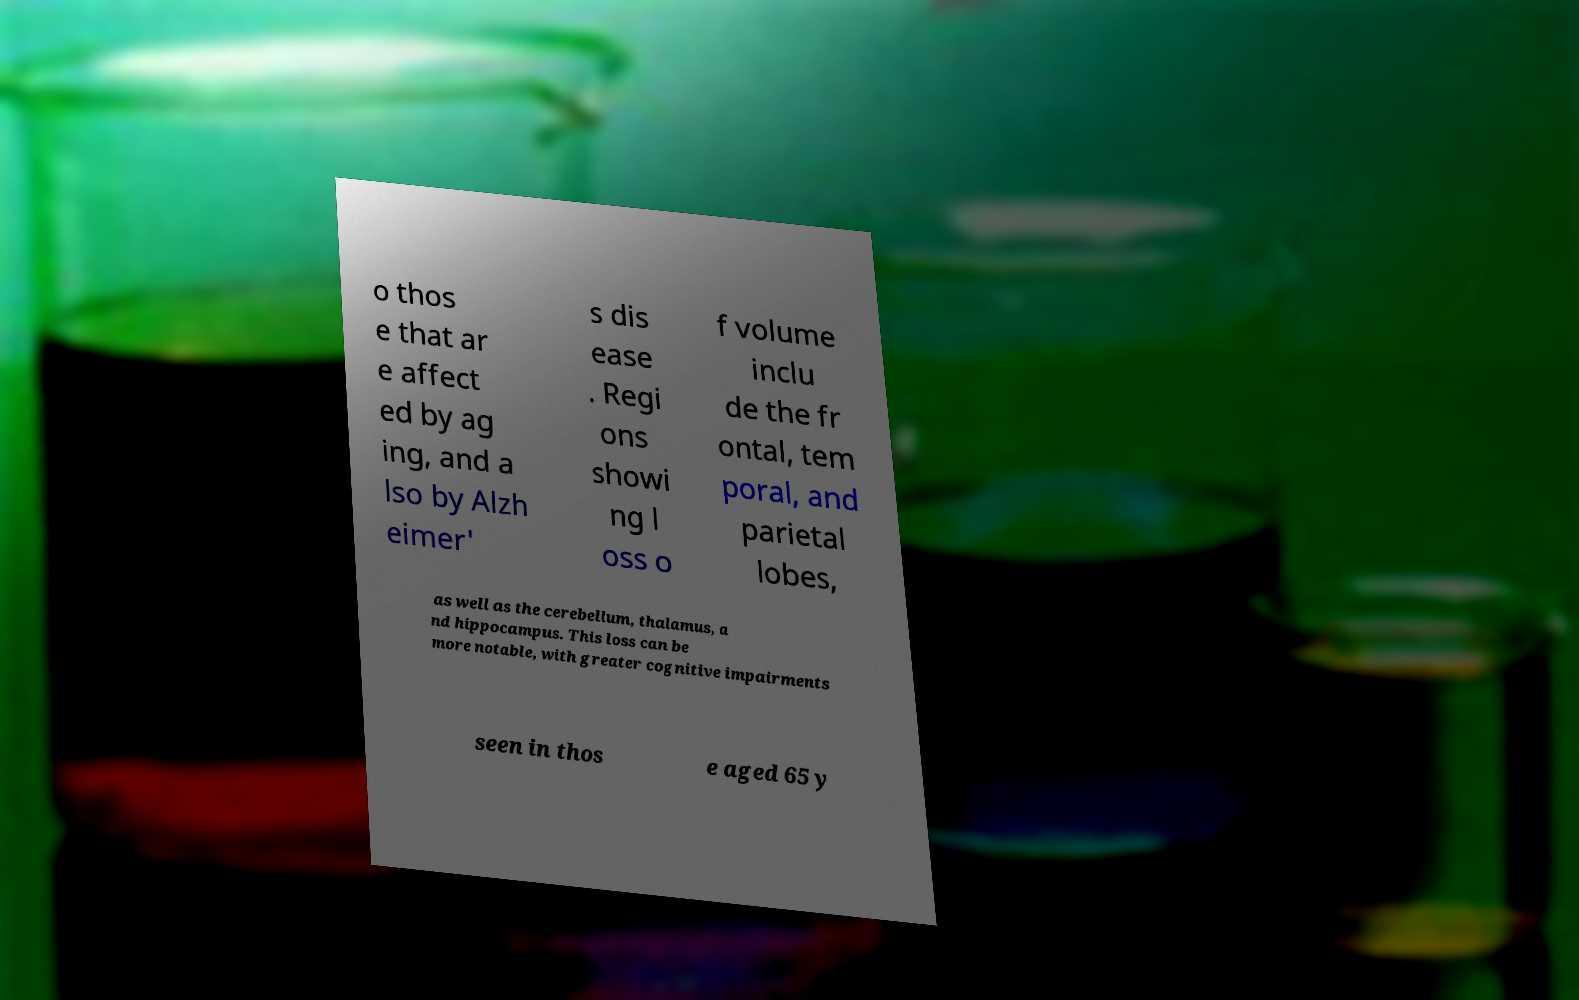I need the written content from this picture converted into text. Can you do that? o thos e that ar e affect ed by ag ing, and a lso by Alzh eimer' s dis ease . Regi ons showi ng l oss o f volume inclu de the fr ontal, tem poral, and parietal lobes, as well as the cerebellum, thalamus, a nd hippocampus. This loss can be more notable, with greater cognitive impairments seen in thos e aged 65 y 